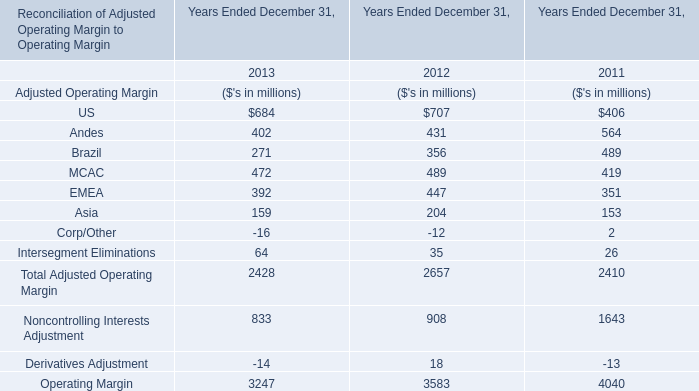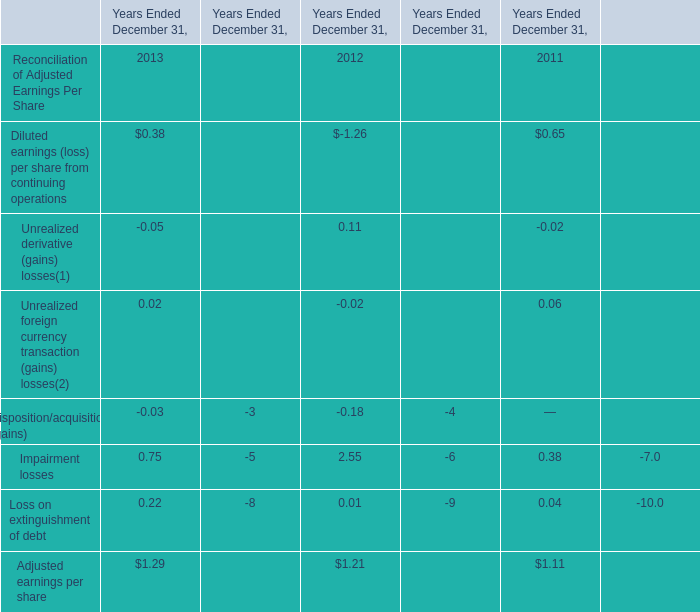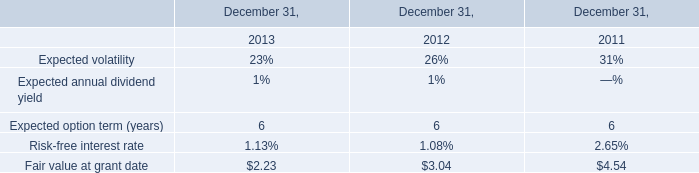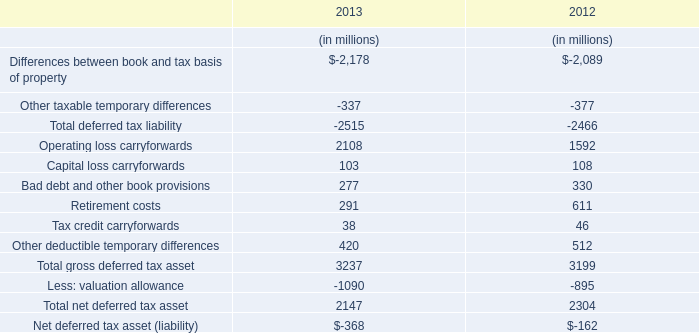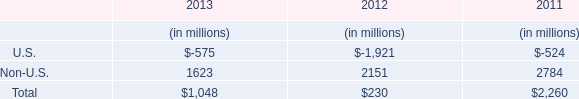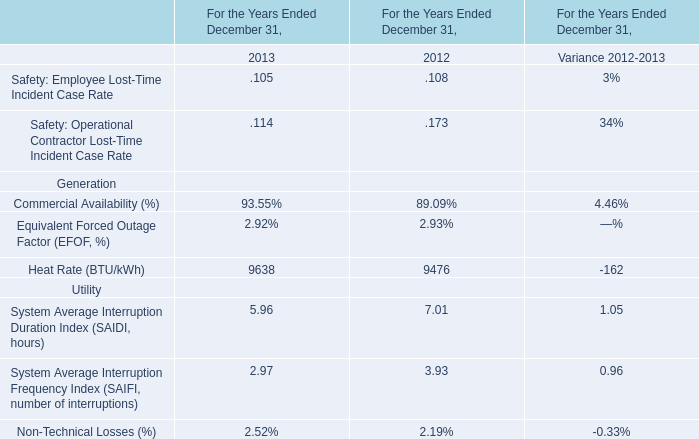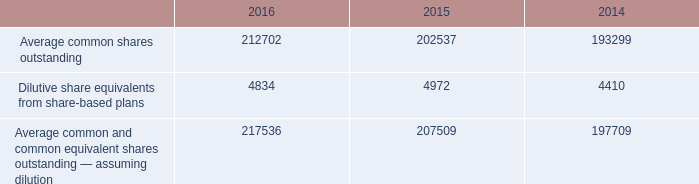What will Asia for Adjusted Operating Margin reach in 2014 if it continues to grow at its current rate? (in million) 
Computations: ((1 + ((159 - 204) / 204)) * 159)
Answer: 123.92647. 